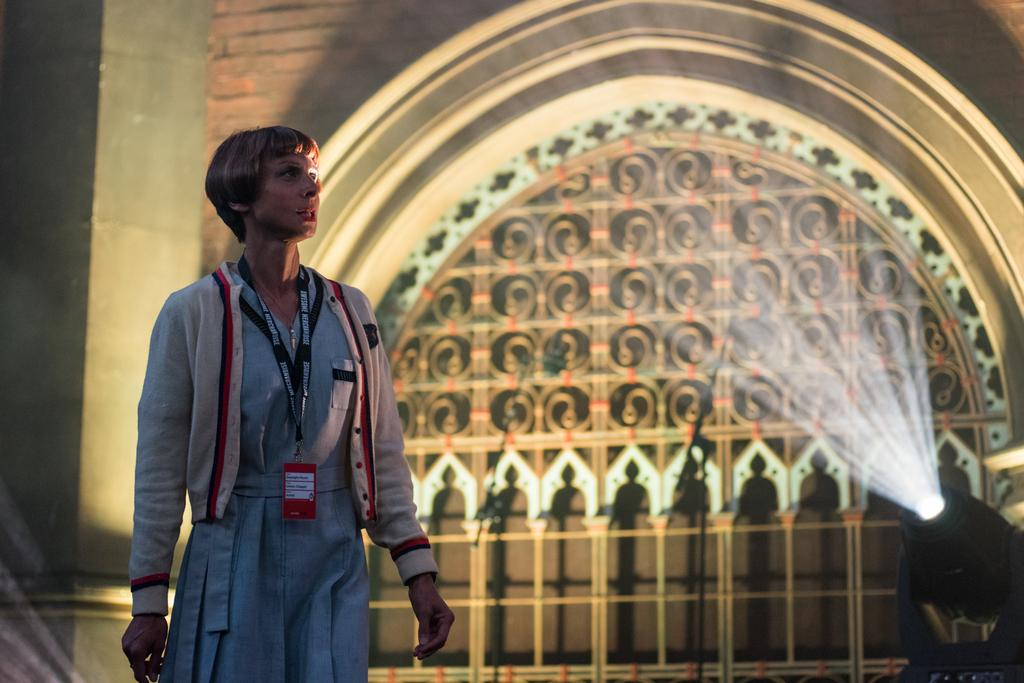What is the main subject of the image? There is a person standing in the image. What can be seen on the right side of the image? There is a focus light on the right side of the image. What is visible in the background of the image? There is a wall and a building in the background of the image. What type of glass is being crushed by the person in the image? There is no glass or crushing activity present in the image. How many fans are visible in the image? There are no fans visible in the image. 